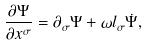Convert formula to latex. <formula><loc_0><loc_0><loc_500><loc_500>\frac { \partial \Psi } { \partial x ^ { \sigma } } = \partial _ { \sigma } \Psi + \omega l _ { \sigma } \dot { \Psi } ,</formula> 